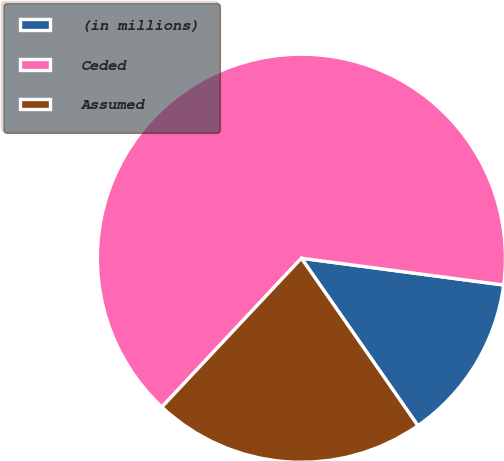Convert chart to OTSL. <chart><loc_0><loc_0><loc_500><loc_500><pie_chart><fcel>(in millions)<fcel>Ceded<fcel>Assumed<nl><fcel>13.23%<fcel>65.11%<fcel>21.66%<nl></chart> 